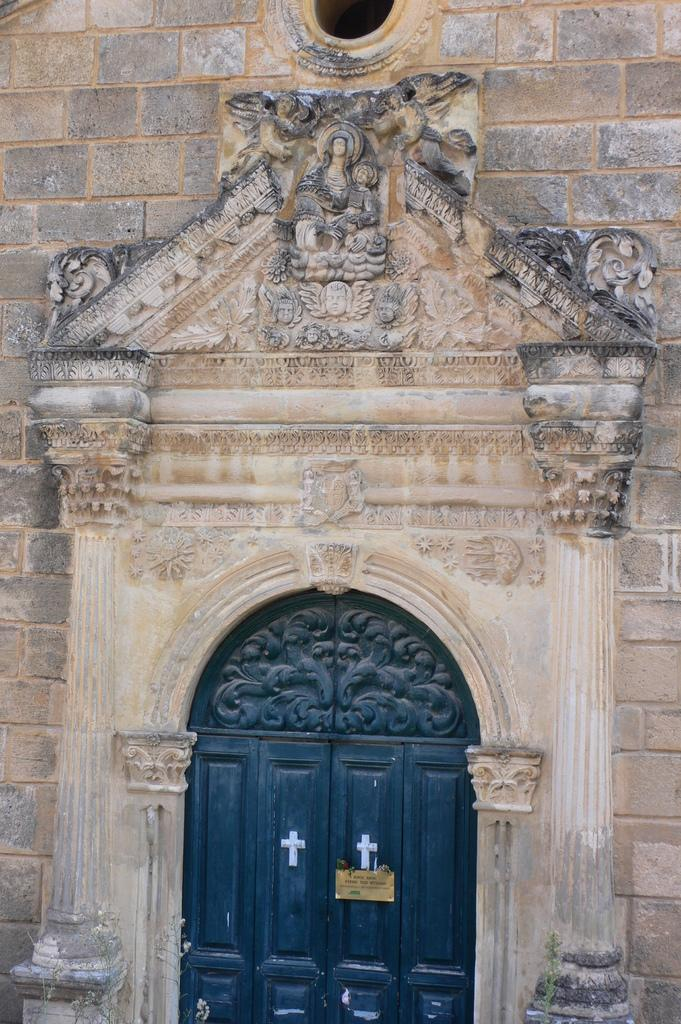What type of structure is depicted in the image? The image contains a church wall. Can you describe any specific features of the wall? There is a door at the bottom of the wall, and sculptures are present in the middle of the wall. What type of fowl can be seen flying around the church wall in the image? There is no fowl present in the image; it only features the church wall with a door and sculptures. How many bags of popcorn are visible on the church wall in the image? There are no bags of popcorn present on the church wall in the image. 